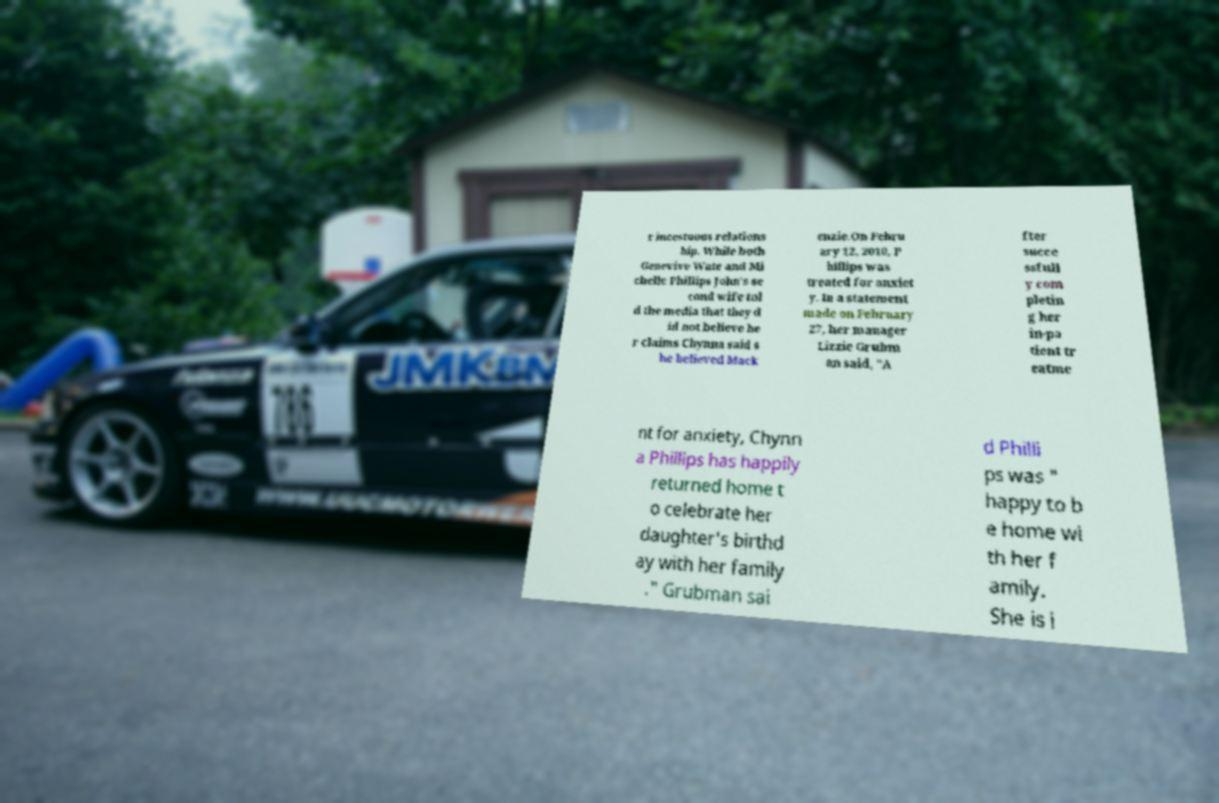Can you read and provide the text displayed in the image?This photo seems to have some interesting text. Can you extract and type it out for me? r incestuous relations hip. While both Genevive Wate and Mi chelle Phillips John's se cond wife tol d the media that they d id not believe he r claims Chynna said s he believed Mack enzie.On Febru ary 12, 2010, P hillips was treated for anxiet y. In a statement made on February 27, her manager Lizzie Grubm an said, "A fter succe ssfull y com pletin g her in-pa tient tr eatme nt for anxiety, Chynn a Phillips has happily returned home t o celebrate her daughter's birthd ay with her family ." Grubman sai d Philli ps was " happy to b e home wi th her f amily. She is i 